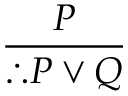<formula> <loc_0><loc_0><loc_500><loc_500>\frac { P } { \therefore P \lor Q }</formula> 